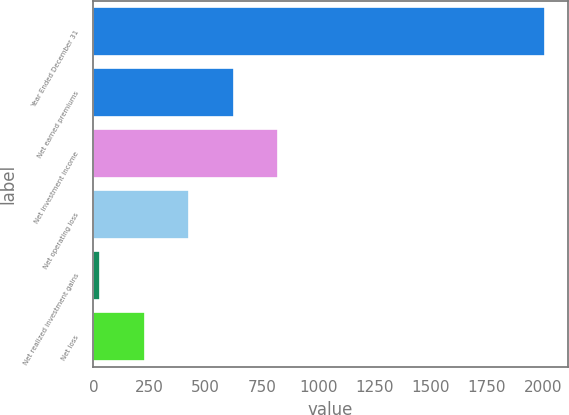Convert chart to OTSL. <chart><loc_0><loc_0><loc_500><loc_500><bar_chart><fcel>Year Ended December 31<fcel>Net earned premiums<fcel>Net investment income<fcel>Net operating loss<fcel>Net realized investment gains<fcel>Net loss<nl><fcel>2010<fcel>624<fcel>822<fcel>426<fcel>30<fcel>228<nl></chart> 